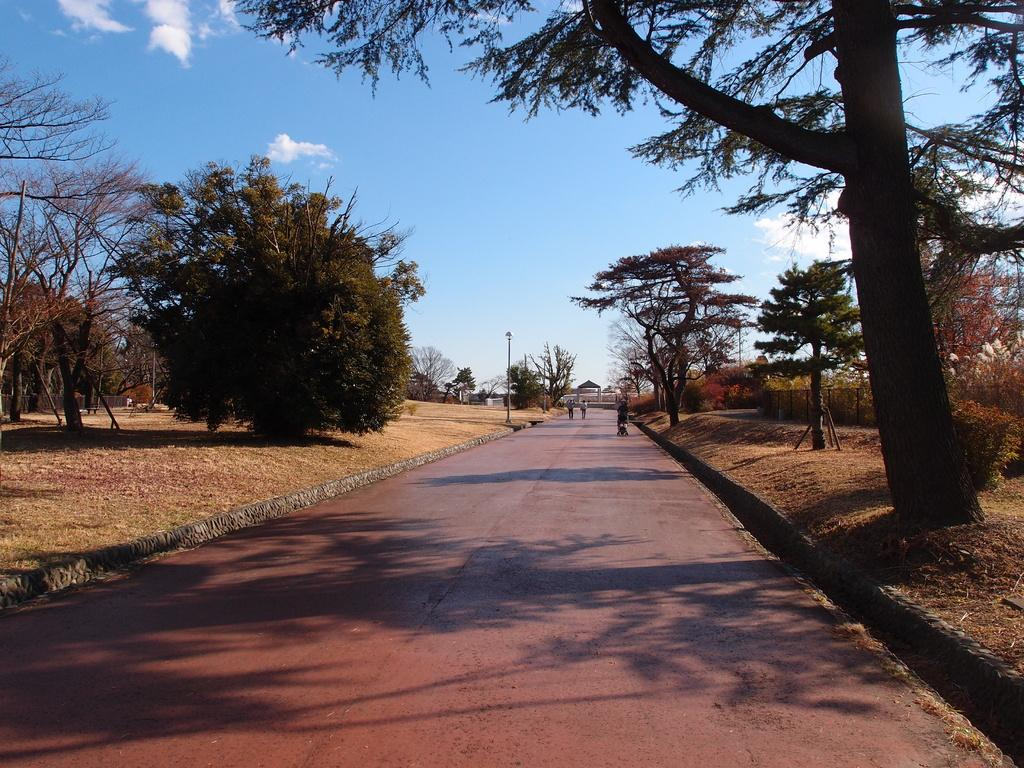What are the people in the image doing? The people in the image are walking on the road. What can be seen beside the road? There are trees beside the road. What else is visible in the image? There are poles visible in the image. What type of cap is the eggnog wearing in the image? There is no eggnog or cap present in the image. 